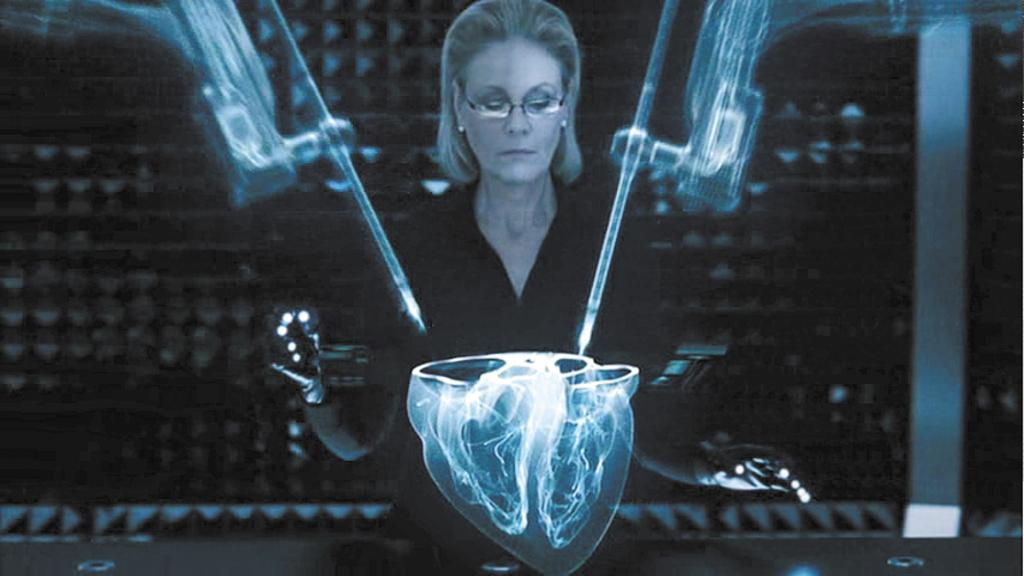Who is the main subject in the image? There is a lady in the image. What accessory is the lady wearing? The lady is wearing specs. Can you describe any visual effects or filters applied to the image? There is a graphical effect on the image. What type of shoes is the lady wearing in the image? There is no mention of shoes in the provided facts, so we cannot determine what type of shoes the lady is wearing. 